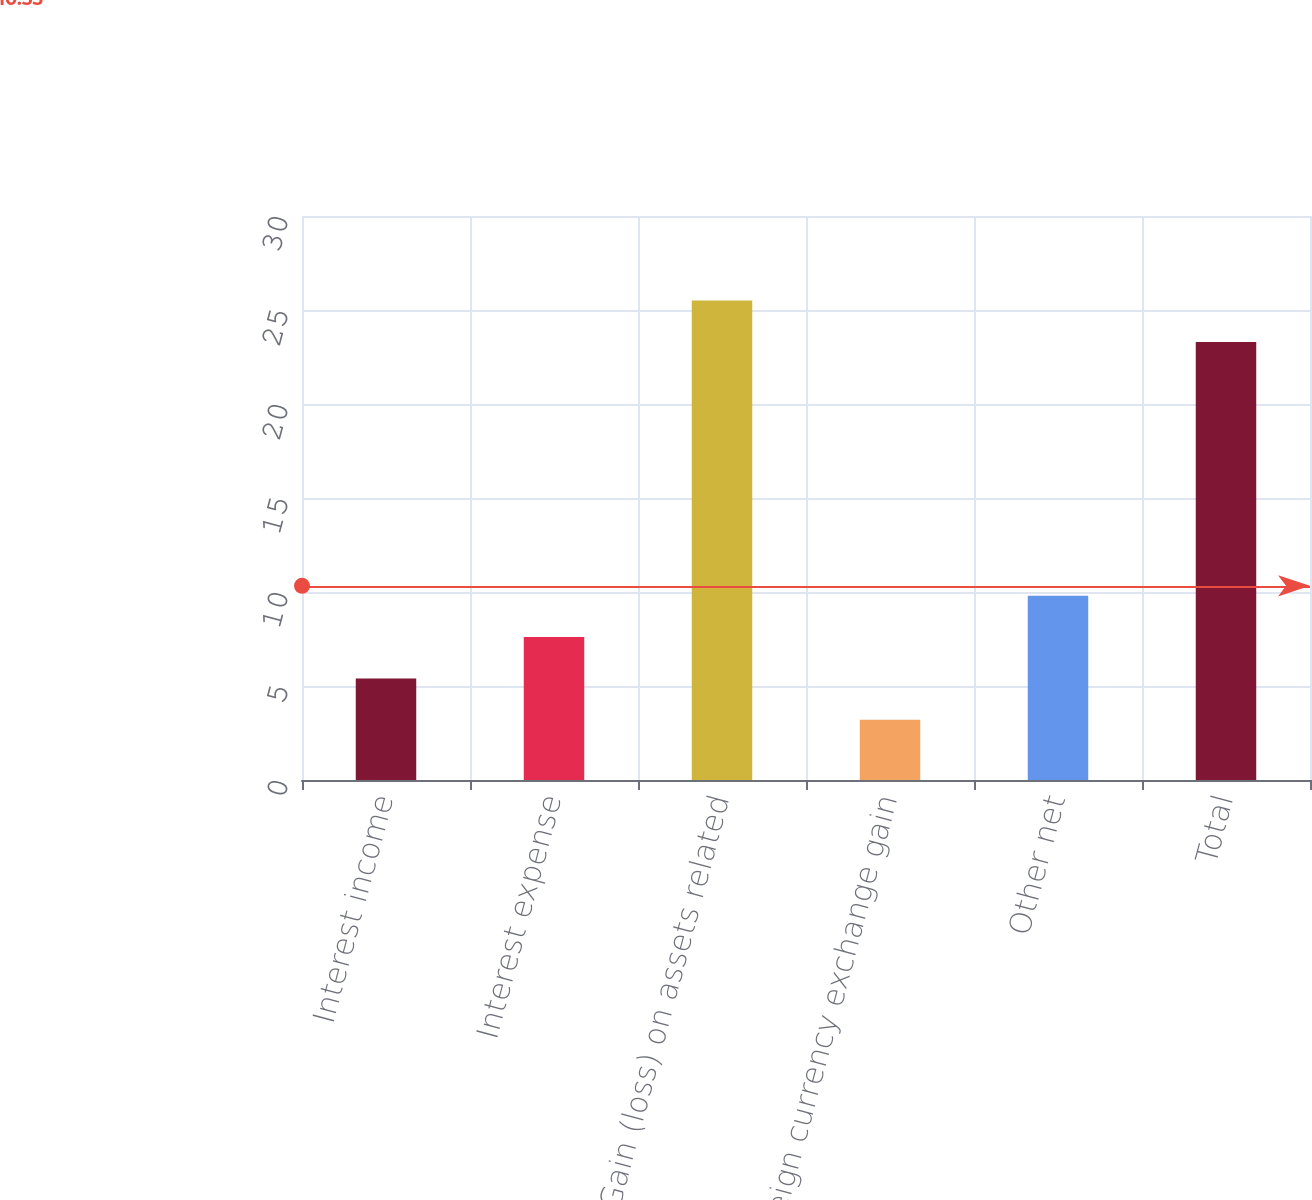Convert chart. <chart><loc_0><loc_0><loc_500><loc_500><bar_chart><fcel>Interest income<fcel>Interest expense<fcel>Gain (loss) on assets related<fcel>Foreign currency exchange gain<fcel>Other net<fcel>Total<nl><fcel>5.4<fcel>7.6<fcel>25.5<fcel>3.2<fcel>9.8<fcel>23.3<nl></chart> 